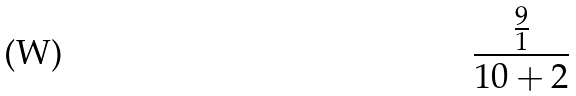<formula> <loc_0><loc_0><loc_500><loc_500>\frac { \frac { 9 } { 1 } } { 1 0 + 2 }</formula> 